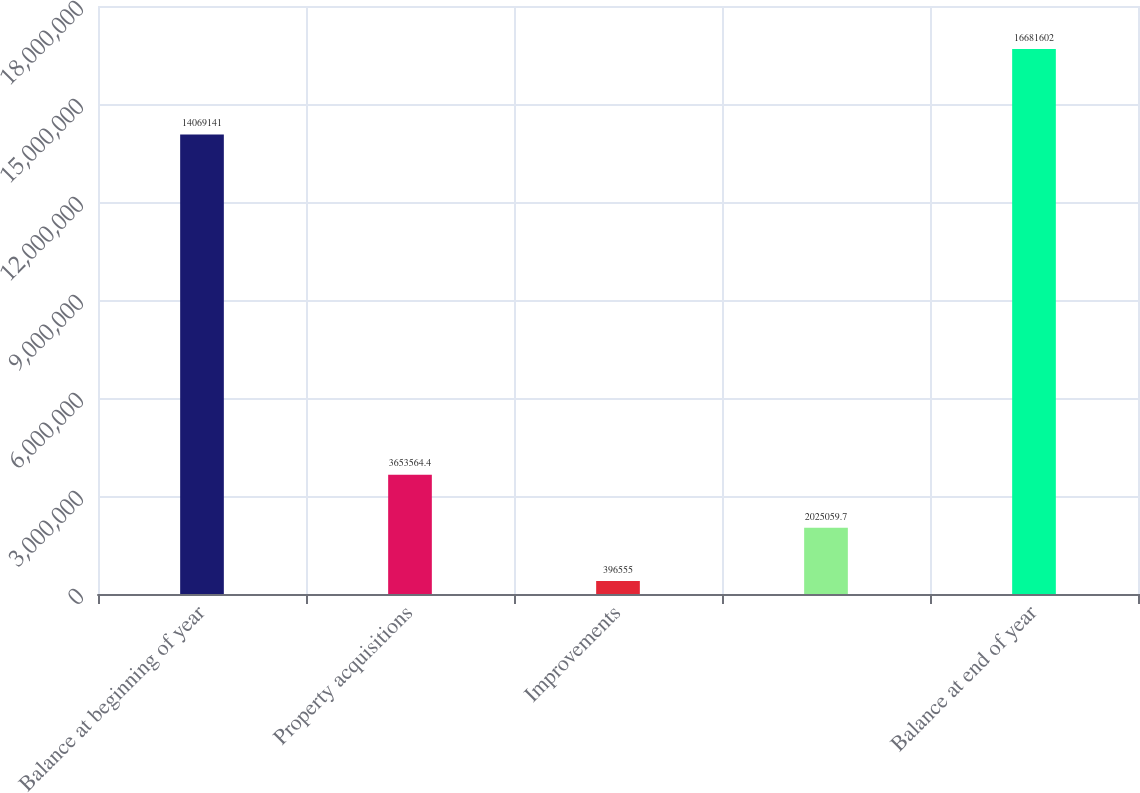<chart> <loc_0><loc_0><loc_500><loc_500><bar_chart><fcel>Balance at beginning of year<fcel>Property acquisitions<fcel>Improvements<fcel>Unnamed: 3<fcel>Balance at end of year<nl><fcel>1.40691e+07<fcel>3.65356e+06<fcel>396555<fcel>2.02506e+06<fcel>1.66816e+07<nl></chart> 